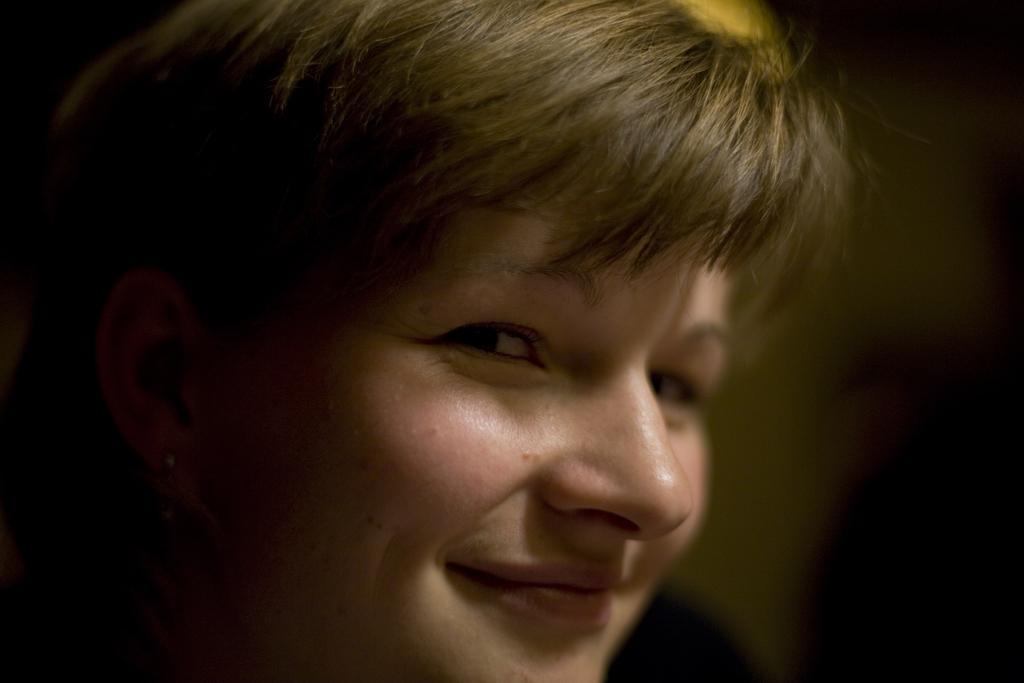How would you summarize this image in a sentence or two? This is a zoomed in picture. In the foreground we can see the head of a person and the person is smiling. The background of the image is blurry. 